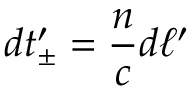<formula> <loc_0><loc_0><loc_500><loc_500>d t _ { \pm } ^ { \prime } = { \frac { n } { c } } d \ell ^ { \prime }</formula> 